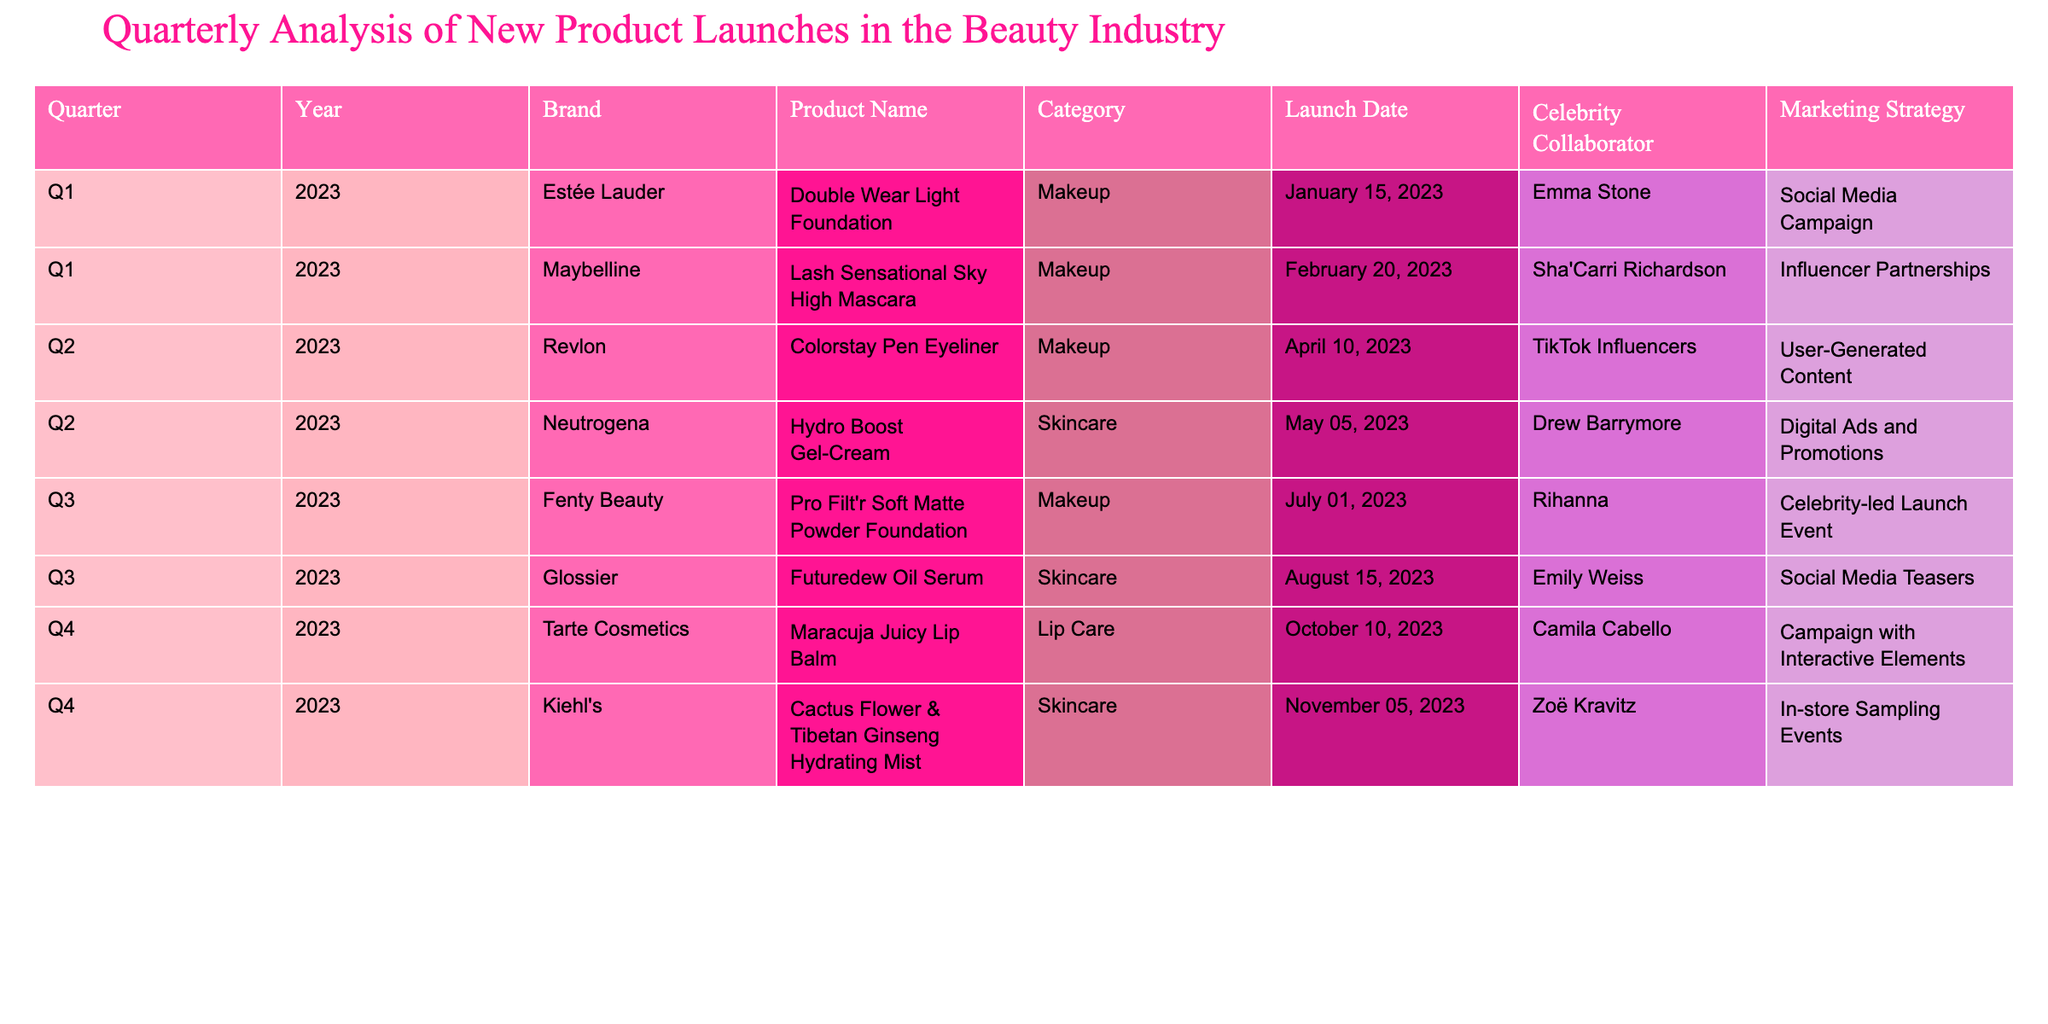What product did Estée Lauder launch in Q1 2023? The table states that Estée Lauder launched the "Double Wear Light Foundation" in Q1 2023.
Answer: Double Wear Light Foundation Who collaborated with Revlon for their Q2 2023 product? The table shows that Revlon's collaboration for the "Colorstay Pen Eyeliner" in Q2 2023 was with TikTok Influencers.
Answer: TikTok Influencers Which category had the most product launches in 2023? Counting the products, Makeup has 5 launches (Estée Lauder, Maybelline, Revlon, Fenty Beauty) while Skincare has 3 (Neutrogena, Glossier, Kiehl's) and Lip Care has 1 (Tarte Cosmetics). The most is Makeup with 5 launches.
Answer: Makeup Did any brand launch more than one product in 2023? Based on the table, no brand is listed as having more than one product launch in 2023; each brand launched only one product.
Answer: No What was the marketing strategy for Fenty Beauty's product launch in Q3 2023? The table indicates that Fenty Beauty's marketing strategy for the "Pro Filt'r Soft Matte Powder Foundation" was a celebrity-led launch event.
Answer: Celebrity-led launch event How many different celebrity collaborators were featured in Q4 2023? The table lists the collaborators for Q4: Camila Cabello for Tarte Cosmetics and Zoë Kravitz for Kiehl's, totaling 2 different celebrity collaborators.
Answer: 2 Which launch was associated with social media teasers? According to the table, Glossier's "Futuredew Oil Serum" in Q3 2023 was associated with social media teasers.
Answer: Futuredew Oil Serum What is the time gap between the launch of Neutrogena's Hydro Boost Gel-Cream and Kiehl's Hydrating Mist? From the table, Neutrogena's launch date is May 5, 2023, and Kiehl's is November 5, 2023. The time gap is 6 months, or exactly 6 months.
Answer: 6 months 